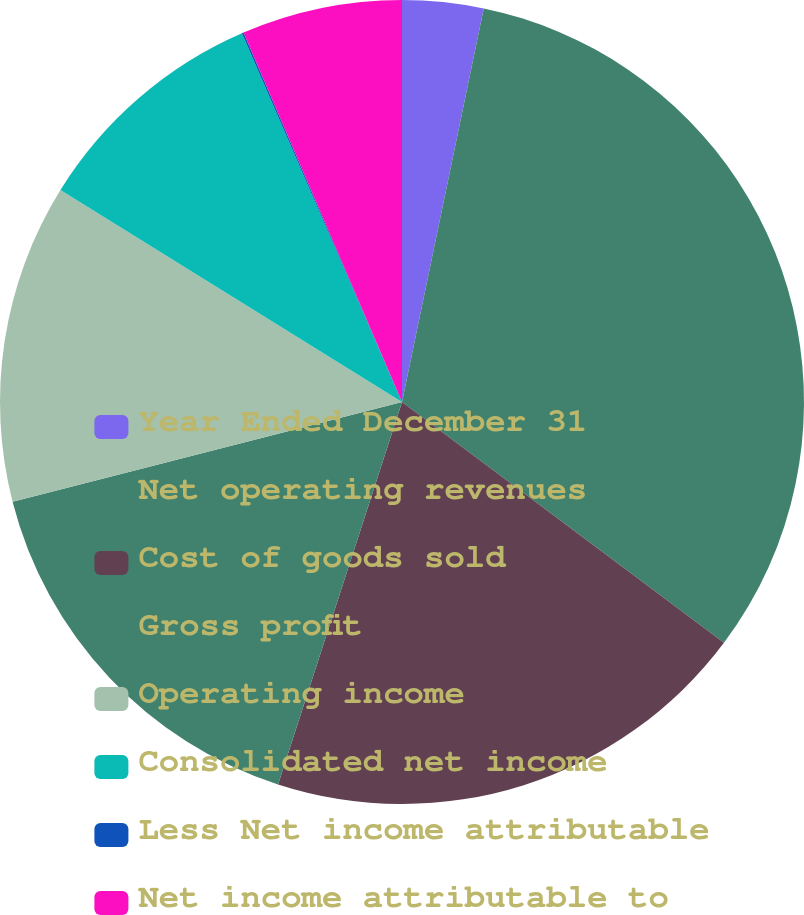Convert chart to OTSL. <chart><loc_0><loc_0><loc_500><loc_500><pie_chart><fcel>Year Ended December 31<fcel>Net operating revenues<fcel>Cost of goods sold<fcel>Gross profit<fcel>Operating income<fcel>Consolidated net income<fcel>Less Net income attributable<fcel>Net income attributable to<nl><fcel>3.26%<fcel>31.96%<fcel>19.77%<fcel>16.02%<fcel>12.83%<fcel>9.64%<fcel>0.07%<fcel>6.45%<nl></chart> 